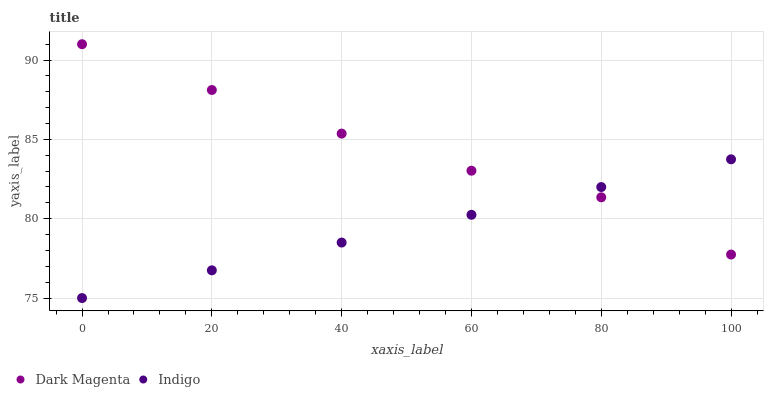Does Indigo have the minimum area under the curve?
Answer yes or no. Yes. Does Dark Magenta have the maximum area under the curve?
Answer yes or no. Yes. Does Dark Magenta have the minimum area under the curve?
Answer yes or no. No. Is Indigo the smoothest?
Answer yes or no. Yes. Is Dark Magenta the roughest?
Answer yes or no. Yes. Is Dark Magenta the smoothest?
Answer yes or no. No. Does Indigo have the lowest value?
Answer yes or no. Yes. Does Dark Magenta have the lowest value?
Answer yes or no. No. Does Dark Magenta have the highest value?
Answer yes or no. Yes. Does Indigo intersect Dark Magenta?
Answer yes or no. Yes. Is Indigo less than Dark Magenta?
Answer yes or no. No. Is Indigo greater than Dark Magenta?
Answer yes or no. No. 